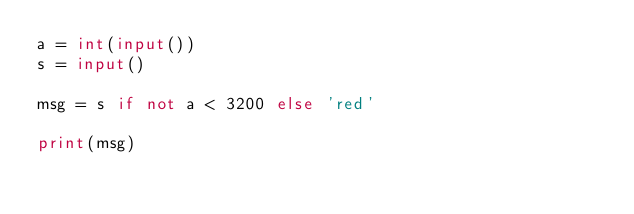Convert code to text. <code><loc_0><loc_0><loc_500><loc_500><_Python_>a = int(input())
s = input()

msg = s if not a < 3200 else 'red'

print(msg)
</code> 